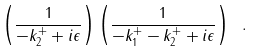<formula> <loc_0><loc_0><loc_500><loc_500>\left ( \frac { 1 } { - k _ { 2 } ^ { + } + i \epsilon } \right ) \left ( \frac { 1 } { - k _ { 1 } ^ { + } - k _ { 2 } ^ { + } + i \epsilon } \right ) \ .</formula> 